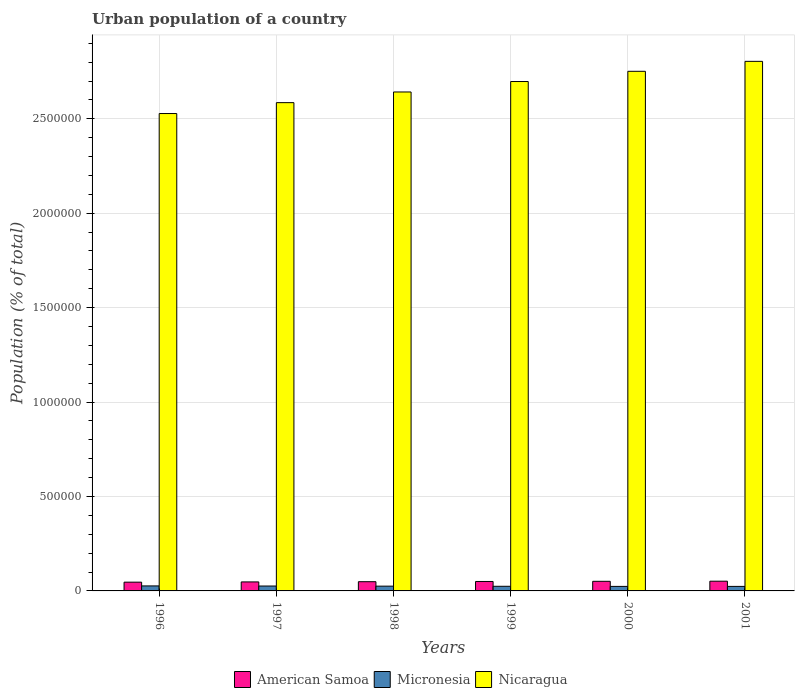Are the number of bars per tick equal to the number of legend labels?
Provide a succinct answer. Yes. Are the number of bars on each tick of the X-axis equal?
Offer a very short reply. Yes. What is the label of the 3rd group of bars from the left?
Offer a very short reply. 1998. What is the urban population in American Samoa in 1997?
Your response must be concise. 4.77e+04. Across all years, what is the maximum urban population in American Samoa?
Give a very brief answer. 5.15e+04. Across all years, what is the minimum urban population in Micronesia?
Ensure brevity in your answer.  2.39e+04. In which year was the urban population in American Samoa maximum?
Offer a very short reply. 2001. What is the total urban population in American Samoa in the graph?
Provide a succinct answer. 2.95e+05. What is the difference between the urban population in Nicaragua in 1998 and the urban population in American Samoa in 1996?
Make the answer very short. 2.60e+06. What is the average urban population in American Samoa per year?
Ensure brevity in your answer.  4.92e+04. In the year 1999, what is the difference between the urban population in Nicaragua and urban population in American Samoa?
Your answer should be very brief. 2.65e+06. In how many years, is the urban population in American Samoa greater than 2600000 %?
Offer a terse response. 0. What is the ratio of the urban population in Nicaragua in 1997 to that in 2001?
Offer a terse response. 0.92. Is the urban population in American Samoa in 1998 less than that in 1999?
Keep it short and to the point. Yes. What is the difference between the highest and the second highest urban population in American Samoa?
Make the answer very short. 524. What is the difference between the highest and the lowest urban population in American Samoa?
Ensure brevity in your answer.  5081. In how many years, is the urban population in American Samoa greater than the average urban population in American Samoa taken over all years?
Offer a terse response. 3. What does the 1st bar from the left in 1998 represents?
Your answer should be compact. American Samoa. What does the 2nd bar from the right in 2001 represents?
Offer a very short reply. Micronesia. Is it the case that in every year, the sum of the urban population in American Samoa and urban population in Micronesia is greater than the urban population in Nicaragua?
Your answer should be compact. No. How many bars are there?
Give a very brief answer. 18. What is the difference between two consecutive major ticks on the Y-axis?
Your answer should be compact. 5.00e+05. Does the graph contain grids?
Ensure brevity in your answer.  Yes. Where does the legend appear in the graph?
Keep it short and to the point. Bottom center. What is the title of the graph?
Make the answer very short. Urban population of a country. What is the label or title of the Y-axis?
Give a very brief answer. Population (% of total). What is the Population (% of total) of American Samoa in 1996?
Ensure brevity in your answer.  4.64e+04. What is the Population (% of total) in Micronesia in 1996?
Make the answer very short. 2.65e+04. What is the Population (% of total) in Nicaragua in 1996?
Offer a very short reply. 2.53e+06. What is the Population (% of total) in American Samoa in 1997?
Provide a short and direct response. 4.77e+04. What is the Population (% of total) in Micronesia in 1997?
Offer a very short reply. 2.59e+04. What is the Population (% of total) of Nicaragua in 1997?
Your answer should be compact. 2.59e+06. What is the Population (% of total) of American Samoa in 1998?
Keep it short and to the point. 4.89e+04. What is the Population (% of total) of Micronesia in 1998?
Make the answer very short. 2.52e+04. What is the Population (% of total) in Nicaragua in 1998?
Offer a very short reply. 2.64e+06. What is the Population (% of total) of American Samoa in 1999?
Ensure brevity in your answer.  5.00e+04. What is the Population (% of total) in Micronesia in 1999?
Ensure brevity in your answer.  2.45e+04. What is the Population (% of total) of Nicaragua in 1999?
Provide a succinct answer. 2.70e+06. What is the Population (% of total) of American Samoa in 2000?
Ensure brevity in your answer.  5.10e+04. What is the Population (% of total) in Micronesia in 2000?
Give a very brief answer. 2.40e+04. What is the Population (% of total) of Nicaragua in 2000?
Provide a succinct answer. 2.75e+06. What is the Population (% of total) of American Samoa in 2001?
Ensure brevity in your answer.  5.15e+04. What is the Population (% of total) in Micronesia in 2001?
Your response must be concise. 2.39e+04. What is the Population (% of total) in Nicaragua in 2001?
Make the answer very short. 2.80e+06. Across all years, what is the maximum Population (% of total) of American Samoa?
Your response must be concise. 5.15e+04. Across all years, what is the maximum Population (% of total) of Micronesia?
Offer a very short reply. 2.65e+04. Across all years, what is the maximum Population (% of total) of Nicaragua?
Offer a very short reply. 2.80e+06. Across all years, what is the minimum Population (% of total) of American Samoa?
Offer a very short reply. 4.64e+04. Across all years, what is the minimum Population (% of total) in Micronesia?
Offer a terse response. 2.39e+04. Across all years, what is the minimum Population (% of total) in Nicaragua?
Provide a short and direct response. 2.53e+06. What is the total Population (% of total) of American Samoa in the graph?
Offer a terse response. 2.95e+05. What is the total Population (% of total) of Micronesia in the graph?
Make the answer very short. 1.50e+05. What is the total Population (% of total) in Nicaragua in the graph?
Make the answer very short. 1.60e+07. What is the difference between the Population (% of total) of American Samoa in 1996 and that in 1997?
Offer a very short reply. -1274. What is the difference between the Population (% of total) of Micronesia in 1996 and that in 1997?
Your response must be concise. 594. What is the difference between the Population (% of total) in Nicaragua in 1996 and that in 1997?
Offer a terse response. -5.77e+04. What is the difference between the Population (% of total) in American Samoa in 1996 and that in 1998?
Give a very brief answer. -2493. What is the difference between the Population (% of total) in Micronesia in 1996 and that in 1998?
Keep it short and to the point. 1281. What is the difference between the Population (% of total) in Nicaragua in 1996 and that in 1998?
Offer a very short reply. -1.14e+05. What is the difference between the Population (% of total) of American Samoa in 1996 and that in 1999?
Offer a very short reply. -3630. What is the difference between the Population (% of total) in Micronesia in 1996 and that in 1999?
Your answer should be very brief. 1990. What is the difference between the Population (% of total) of Nicaragua in 1996 and that in 1999?
Provide a succinct answer. -1.70e+05. What is the difference between the Population (% of total) of American Samoa in 1996 and that in 2000?
Your response must be concise. -4557. What is the difference between the Population (% of total) of Micronesia in 1996 and that in 2000?
Give a very brief answer. 2526. What is the difference between the Population (% of total) of Nicaragua in 1996 and that in 2000?
Give a very brief answer. -2.24e+05. What is the difference between the Population (% of total) of American Samoa in 1996 and that in 2001?
Offer a terse response. -5081. What is the difference between the Population (% of total) in Micronesia in 1996 and that in 2001?
Your answer should be compact. 2584. What is the difference between the Population (% of total) of Nicaragua in 1996 and that in 2001?
Provide a succinct answer. -2.76e+05. What is the difference between the Population (% of total) in American Samoa in 1997 and that in 1998?
Your answer should be very brief. -1219. What is the difference between the Population (% of total) of Micronesia in 1997 and that in 1998?
Your response must be concise. 687. What is the difference between the Population (% of total) in Nicaragua in 1997 and that in 1998?
Keep it short and to the point. -5.65e+04. What is the difference between the Population (% of total) in American Samoa in 1997 and that in 1999?
Ensure brevity in your answer.  -2356. What is the difference between the Population (% of total) in Micronesia in 1997 and that in 1999?
Your answer should be compact. 1396. What is the difference between the Population (% of total) of Nicaragua in 1997 and that in 1999?
Provide a succinct answer. -1.12e+05. What is the difference between the Population (% of total) in American Samoa in 1997 and that in 2000?
Your response must be concise. -3283. What is the difference between the Population (% of total) in Micronesia in 1997 and that in 2000?
Keep it short and to the point. 1932. What is the difference between the Population (% of total) in Nicaragua in 1997 and that in 2000?
Your response must be concise. -1.66e+05. What is the difference between the Population (% of total) of American Samoa in 1997 and that in 2001?
Make the answer very short. -3807. What is the difference between the Population (% of total) of Micronesia in 1997 and that in 2001?
Make the answer very short. 1990. What is the difference between the Population (% of total) of Nicaragua in 1997 and that in 2001?
Make the answer very short. -2.19e+05. What is the difference between the Population (% of total) of American Samoa in 1998 and that in 1999?
Provide a short and direct response. -1137. What is the difference between the Population (% of total) of Micronesia in 1998 and that in 1999?
Your answer should be very brief. 709. What is the difference between the Population (% of total) of Nicaragua in 1998 and that in 1999?
Give a very brief answer. -5.53e+04. What is the difference between the Population (% of total) of American Samoa in 1998 and that in 2000?
Your response must be concise. -2064. What is the difference between the Population (% of total) in Micronesia in 1998 and that in 2000?
Offer a very short reply. 1245. What is the difference between the Population (% of total) in Nicaragua in 1998 and that in 2000?
Keep it short and to the point. -1.09e+05. What is the difference between the Population (% of total) of American Samoa in 1998 and that in 2001?
Your response must be concise. -2588. What is the difference between the Population (% of total) of Micronesia in 1998 and that in 2001?
Give a very brief answer. 1303. What is the difference between the Population (% of total) of Nicaragua in 1998 and that in 2001?
Offer a very short reply. -1.62e+05. What is the difference between the Population (% of total) in American Samoa in 1999 and that in 2000?
Keep it short and to the point. -927. What is the difference between the Population (% of total) of Micronesia in 1999 and that in 2000?
Offer a very short reply. 536. What is the difference between the Population (% of total) of Nicaragua in 1999 and that in 2000?
Keep it short and to the point. -5.41e+04. What is the difference between the Population (% of total) of American Samoa in 1999 and that in 2001?
Ensure brevity in your answer.  -1451. What is the difference between the Population (% of total) of Micronesia in 1999 and that in 2001?
Provide a short and direct response. 594. What is the difference between the Population (% of total) in Nicaragua in 1999 and that in 2001?
Provide a succinct answer. -1.07e+05. What is the difference between the Population (% of total) of American Samoa in 2000 and that in 2001?
Your response must be concise. -524. What is the difference between the Population (% of total) in Nicaragua in 2000 and that in 2001?
Keep it short and to the point. -5.27e+04. What is the difference between the Population (% of total) in American Samoa in 1996 and the Population (% of total) in Micronesia in 1997?
Your answer should be compact. 2.05e+04. What is the difference between the Population (% of total) in American Samoa in 1996 and the Population (% of total) in Nicaragua in 1997?
Your response must be concise. -2.54e+06. What is the difference between the Population (% of total) in Micronesia in 1996 and the Population (% of total) in Nicaragua in 1997?
Give a very brief answer. -2.56e+06. What is the difference between the Population (% of total) of American Samoa in 1996 and the Population (% of total) of Micronesia in 1998?
Your response must be concise. 2.12e+04. What is the difference between the Population (% of total) of American Samoa in 1996 and the Population (% of total) of Nicaragua in 1998?
Provide a short and direct response. -2.60e+06. What is the difference between the Population (% of total) of Micronesia in 1996 and the Population (% of total) of Nicaragua in 1998?
Your answer should be compact. -2.62e+06. What is the difference between the Population (% of total) in American Samoa in 1996 and the Population (% of total) in Micronesia in 1999?
Provide a succinct answer. 2.19e+04. What is the difference between the Population (% of total) of American Samoa in 1996 and the Population (% of total) of Nicaragua in 1999?
Offer a very short reply. -2.65e+06. What is the difference between the Population (% of total) in Micronesia in 1996 and the Population (% of total) in Nicaragua in 1999?
Your response must be concise. -2.67e+06. What is the difference between the Population (% of total) in American Samoa in 1996 and the Population (% of total) in Micronesia in 2000?
Give a very brief answer. 2.24e+04. What is the difference between the Population (% of total) in American Samoa in 1996 and the Population (% of total) in Nicaragua in 2000?
Give a very brief answer. -2.71e+06. What is the difference between the Population (% of total) in Micronesia in 1996 and the Population (% of total) in Nicaragua in 2000?
Keep it short and to the point. -2.72e+06. What is the difference between the Population (% of total) in American Samoa in 1996 and the Population (% of total) in Micronesia in 2001?
Make the answer very short. 2.25e+04. What is the difference between the Population (% of total) of American Samoa in 1996 and the Population (% of total) of Nicaragua in 2001?
Make the answer very short. -2.76e+06. What is the difference between the Population (% of total) in Micronesia in 1996 and the Population (% of total) in Nicaragua in 2001?
Your answer should be very brief. -2.78e+06. What is the difference between the Population (% of total) in American Samoa in 1997 and the Population (% of total) in Micronesia in 1998?
Offer a terse response. 2.24e+04. What is the difference between the Population (% of total) of American Samoa in 1997 and the Population (% of total) of Nicaragua in 1998?
Give a very brief answer. -2.59e+06. What is the difference between the Population (% of total) in Micronesia in 1997 and the Population (% of total) in Nicaragua in 1998?
Provide a short and direct response. -2.62e+06. What is the difference between the Population (% of total) of American Samoa in 1997 and the Population (% of total) of Micronesia in 1999?
Offer a terse response. 2.31e+04. What is the difference between the Population (% of total) in American Samoa in 1997 and the Population (% of total) in Nicaragua in 1999?
Give a very brief answer. -2.65e+06. What is the difference between the Population (% of total) in Micronesia in 1997 and the Population (% of total) in Nicaragua in 1999?
Ensure brevity in your answer.  -2.67e+06. What is the difference between the Population (% of total) in American Samoa in 1997 and the Population (% of total) in Micronesia in 2000?
Ensure brevity in your answer.  2.37e+04. What is the difference between the Population (% of total) in American Samoa in 1997 and the Population (% of total) in Nicaragua in 2000?
Provide a succinct answer. -2.70e+06. What is the difference between the Population (% of total) in Micronesia in 1997 and the Population (% of total) in Nicaragua in 2000?
Offer a very short reply. -2.73e+06. What is the difference between the Population (% of total) of American Samoa in 1997 and the Population (% of total) of Micronesia in 2001?
Offer a terse response. 2.37e+04. What is the difference between the Population (% of total) in American Samoa in 1997 and the Population (% of total) in Nicaragua in 2001?
Make the answer very short. -2.76e+06. What is the difference between the Population (% of total) in Micronesia in 1997 and the Population (% of total) in Nicaragua in 2001?
Keep it short and to the point. -2.78e+06. What is the difference between the Population (% of total) of American Samoa in 1998 and the Population (% of total) of Micronesia in 1999?
Your response must be concise. 2.44e+04. What is the difference between the Population (% of total) in American Samoa in 1998 and the Population (% of total) in Nicaragua in 1999?
Offer a terse response. -2.65e+06. What is the difference between the Population (% of total) in Micronesia in 1998 and the Population (% of total) in Nicaragua in 1999?
Offer a terse response. -2.67e+06. What is the difference between the Population (% of total) in American Samoa in 1998 and the Population (% of total) in Micronesia in 2000?
Your answer should be very brief. 2.49e+04. What is the difference between the Population (% of total) of American Samoa in 1998 and the Population (% of total) of Nicaragua in 2000?
Offer a terse response. -2.70e+06. What is the difference between the Population (% of total) of Micronesia in 1998 and the Population (% of total) of Nicaragua in 2000?
Your answer should be very brief. -2.73e+06. What is the difference between the Population (% of total) of American Samoa in 1998 and the Population (% of total) of Micronesia in 2001?
Your answer should be very brief. 2.50e+04. What is the difference between the Population (% of total) of American Samoa in 1998 and the Population (% of total) of Nicaragua in 2001?
Provide a short and direct response. -2.76e+06. What is the difference between the Population (% of total) of Micronesia in 1998 and the Population (% of total) of Nicaragua in 2001?
Your answer should be very brief. -2.78e+06. What is the difference between the Population (% of total) of American Samoa in 1999 and the Population (% of total) of Micronesia in 2000?
Make the answer very short. 2.60e+04. What is the difference between the Population (% of total) of American Samoa in 1999 and the Population (% of total) of Nicaragua in 2000?
Your response must be concise. -2.70e+06. What is the difference between the Population (% of total) of Micronesia in 1999 and the Population (% of total) of Nicaragua in 2000?
Ensure brevity in your answer.  -2.73e+06. What is the difference between the Population (% of total) in American Samoa in 1999 and the Population (% of total) in Micronesia in 2001?
Keep it short and to the point. 2.61e+04. What is the difference between the Population (% of total) in American Samoa in 1999 and the Population (% of total) in Nicaragua in 2001?
Provide a succinct answer. -2.75e+06. What is the difference between the Population (% of total) in Micronesia in 1999 and the Population (% of total) in Nicaragua in 2001?
Give a very brief answer. -2.78e+06. What is the difference between the Population (% of total) in American Samoa in 2000 and the Population (% of total) in Micronesia in 2001?
Make the answer very short. 2.70e+04. What is the difference between the Population (% of total) in American Samoa in 2000 and the Population (% of total) in Nicaragua in 2001?
Offer a very short reply. -2.75e+06. What is the difference between the Population (% of total) in Micronesia in 2000 and the Population (% of total) in Nicaragua in 2001?
Ensure brevity in your answer.  -2.78e+06. What is the average Population (% of total) in American Samoa per year?
Provide a succinct answer. 4.92e+04. What is the average Population (% of total) of Micronesia per year?
Your answer should be compact. 2.50e+04. What is the average Population (% of total) of Nicaragua per year?
Ensure brevity in your answer.  2.67e+06. In the year 1996, what is the difference between the Population (% of total) in American Samoa and Population (% of total) in Micronesia?
Your answer should be compact. 1.99e+04. In the year 1996, what is the difference between the Population (% of total) of American Samoa and Population (% of total) of Nicaragua?
Offer a terse response. -2.48e+06. In the year 1996, what is the difference between the Population (% of total) in Micronesia and Population (% of total) in Nicaragua?
Your answer should be compact. -2.50e+06. In the year 1997, what is the difference between the Population (% of total) of American Samoa and Population (% of total) of Micronesia?
Your answer should be compact. 2.18e+04. In the year 1997, what is the difference between the Population (% of total) in American Samoa and Population (% of total) in Nicaragua?
Give a very brief answer. -2.54e+06. In the year 1997, what is the difference between the Population (% of total) of Micronesia and Population (% of total) of Nicaragua?
Keep it short and to the point. -2.56e+06. In the year 1998, what is the difference between the Population (% of total) in American Samoa and Population (% of total) in Micronesia?
Offer a very short reply. 2.37e+04. In the year 1998, what is the difference between the Population (% of total) in American Samoa and Population (% of total) in Nicaragua?
Make the answer very short. -2.59e+06. In the year 1998, what is the difference between the Population (% of total) of Micronesia and Population (% of total) of Nicaragua?
Keep it short and to the point. -2.62e+06. In the year 1999, what is the difference between the Population (% of total) in American Samoa and Population (% of total) in Micronesia?
Offer a terse response. 2.55e+04. In the year 1999, what is the difference between the Population (% of total) in American Samoa and Population (% of total) in Nicaragua?
Make the answer very short. -2.65e+06. In the year 1999, what is the difference between the Population (% of total) of Micronesia and Population (% of total) of Nicaragua?
Your response must be concise. -2.67e+06. In the year 2000, what is the difference between the Population (% of total) in American Samoa and Population (% of total) in Micronesia?
Your answer should be compact. 2.70e+04. In the year 2000, what is the difference between the Population (% of total) in American Samoa and Population (% of total) in Nicaragua?
Your answer should be compact. -2.70e+06. In the year 2000, what is the difference between the Population (% of total) in Micronesia and Population (% of total) in Nicaragua?
Provide a succinct answer. -2.73e+06. In the year 2001, what is the difference between the Population (% of total) of American Samoa and Population (% of total) of Micronesia?
Your answer should be very brief. 2.76e+04. In the year 2001, what is the difference between the Population (% of total) of American Samoa and Population (% of total) of Nicaragua?
Ensure brevity in your answer.  -2.75e+06. In the year 2001, what is the difference between the Population (% of total) of Micronesia and Population (% of total) of Nicaragua?
Offer a terse response. -2.78e+06. What is the ratio of the Population (% of total) in American Samoa in 1996 to that in 1997?
Your answer should be compact. 0.97. What is the ratio of the Population (% of total) in Micronesia in 1996 to that in 1997?
Ensure brevity in your answer.  1.02. What is the ratio of the Population (% of total) of Nicaragua in 1996 to that in 1997?
Make the answer very short. 0.98. What is the ratio of the Population (% of total) of American Samoa in 1996 to that in 1998?
Your response must be concise. 0.95. What is the ratio of the Population (% of total) of Micronesia in 1996 to that in 1998?
Give a very brief answer. 1.05. What is the ratio of the Population (% of total) of Nicaragua in 1996 to that in 1998?
Keep it short and to the point. 0.96. What is the ratio of the Population (% of total) in American Samoa in 1996 to that in 1999?
Your answer should be compact. 0.93. What is the ratio of the Population (% of total) of Micronesia in 1996 to that in 1999?
Make the answer very short. 1.08. What is the ratio of the Population (% of total) in Nicaragua in 1996 to that in 1999?
Offer a terse response. 0.94. What is the ratio of the Population (% of total) of American Samoa in 1996 to that in 2000?
Your response must be concise. 0.91. What is the ratio of the Population (% of total) in Micronesia in 1996 to that in 2000?
Your answer should be very brief. 1.11. What is the ratio of the Population (% of total) in Nicaragua in 1996 to that in 2000?
Give a very brief answer. 0.92. What is the ratio of the Population (% of total) in American Samoa in 1996 to that in 2001?
Your response must be concise. 0.9. What is the ratio of the Population (% of total) of Micronesia in 1996 to that in 2001?
Ensure brevity in your answer.  1.11. What is the ratio of the Population (% of total) in Nicaragua in 1996 to that in 2001?
Keep it short and to the point. 0.9. What is the ratio of the Population (% of total) of American Samoa in 1997 to that in 1998?
Offer a very short reply. 0.98. What is the ratio of the Population (% of total) of Micronesia in 1997 to that in 1998?
Give a very brief answer. 1.03. What is the ratio of the Population (% of total) in Nicaragua in 1997 to that in 1998?
Your answer should be compact. 0.98. What is the ratio of the Population (% of total) in American Samoa in 1997 to that in 1999?
Offer a terse response. 0.95. What is the ratio of the Population (% of total) in Micronesia in 1997 to that in 1999?
Your answer should be compact. 1.06. What is the ratio of the Population (% of total) of Nicaragua in 1997 to that in 1999?
Your response must be concise. 0.96. What is the ratio of the Population (% of total) in American Samoa in 1997 to that in 2000?
Your response must be concise. 0.94. What is the ratio of the Population (% of total) in Micronesia in 1997 to that in 2000?
Give a very brief answer. 1.08. What is the ratio of the Population (% of total) in Nicaragua in 1997 to that in 2000?
Your answer should be compact. 0.94. What is the ratio of the Population (% of total) in American Samoa in 1997 to that in 2001?
Provide a short and direct response. 0.93. What is the ratio of the Population (% of total) in Micronesia in 1997 to that in 2001?
Offer a terse response. 1.08. What is the ratio of the Population (% of total) of Nicaragua in 1997 to that in 2001?
Ensure brevity in your answer.  0.92. What is the ratio of the Population (% of total) in American Samoa in 1998 to that in 1999?
Provide a short and direct response. 0.98. What is the ratio of the Population (% of total) of Micronesia in 1998 to that in 1999?
Give a very brief answer. 1.03. What is the ratio of the Population (% of total) of Nicaragua in 1998 to that in 1999?
Make the answer very short. 0.98. What is the ratio of the Population (% of total) in American Samoa in 1998 to that in 2000?
Your answer should be very brief. 0.96. What is the ratio of the Population (% of total) of Micronesia in 1998 to that in 2000?
Provide a succinct answer. 1.05. What is the ratio of the Population (% of total) of Nicaragua in 1998 to that in 2000?
Offer a terse response. 0.96. What is the ratio of the Population (% of total) of American Samoa in 1998 to that in 2001?
Give a very brief answer. 0.95. What is the ratio of the Population (% of total) of Micronesia in 1998 to that in 2001?
Ensure brevity in your answer.  1.05. What is the ratio of the Population (% of total) of Nicaragua in 1998 to that in 2001?
Provide a short and direct response. 0.94. What is the ratio of the Population (% of total) of American Samoa in 1999 to that in 2000?
Your answer should be compact. 0.98. What is the ratio of the Population (% of total) of Micronesia in 1999 to that in 2000?
Your response must be concise. 1.02. What is the ratio of the Population (% of total) in Nicaragua in 1999 to that in 2000?
Your answer should be compact. 0.98. What is the ratio of the Population (% of total) in American Samoa in 1999 to that in 2001?
Offer a terse response. 0.97. What is the ratio of the Population (% of total) of Micronesia in 1999 to that in 2001?
Your answer should be compact. 1.02. What is the ratio of the Population (% of total) in Nicaragua in 1999 to that in 2001?
Give a very brief answer. 0.96. What is the ratio of the Population (% of total) of Micronesia in 2000 to that in 2001?
Provide a succinct answer. 1. What is the ratio of the Population (% of total) of Nicaragua in 2000 to that in 2001?
Your answer should be compact. 0.98. What is the difference between the highest and the second highest Population (% of total) in American Samoa?
Provide a short and direct response. 524. What is the difference between the highest and the second highest Population (% of total) of Micronesia?
Keep it short and to the point. 594. What is the difference between the highest and the second highest Population (% of total) of Nicaragua?
Keep it short and to the point. 5.27e+04. What is the difference between the highest and the lowest Population (% of total) in American Samoa?
Offer a very short reply. 5081. What is the difference between the highest and the lowest Population (% of total) of Micronesia?
Give a very brief answer. 2584. What is the difference between the highest and the lowest Population (% of total) of Nicaragua?
Provide a succinct answer. 2.76e+05. 